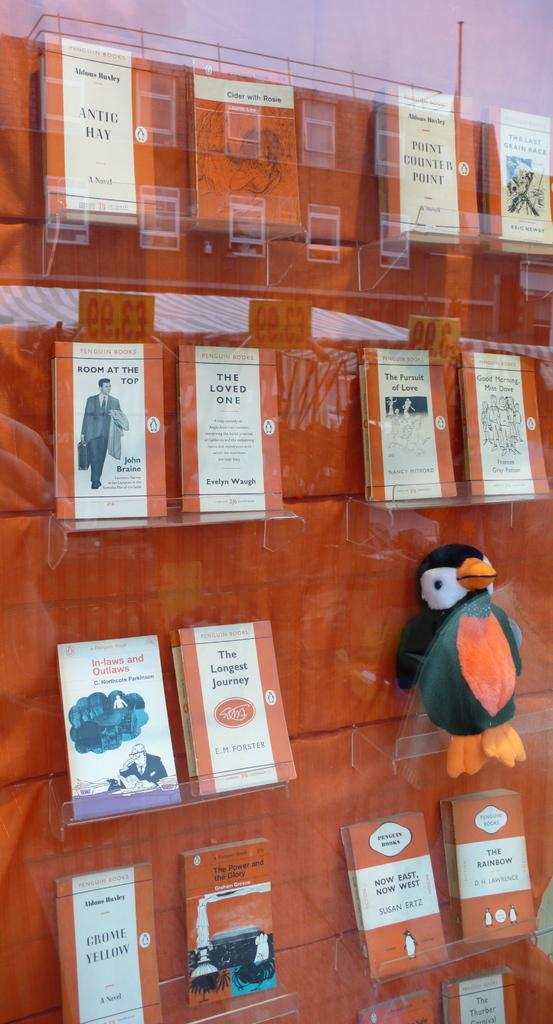<image>
Offer a succinct explanation of the picture presented. Various orange books in a display case including The Loved One by Evelyn Waugh. 